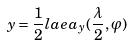<formula> <loc_0><loc_0><loc_500><loc_500>y = \frac { 1 } { 2 } l a e a _ { y } ( \frac { \lambda } { 2 } , \varphi )</formula> 